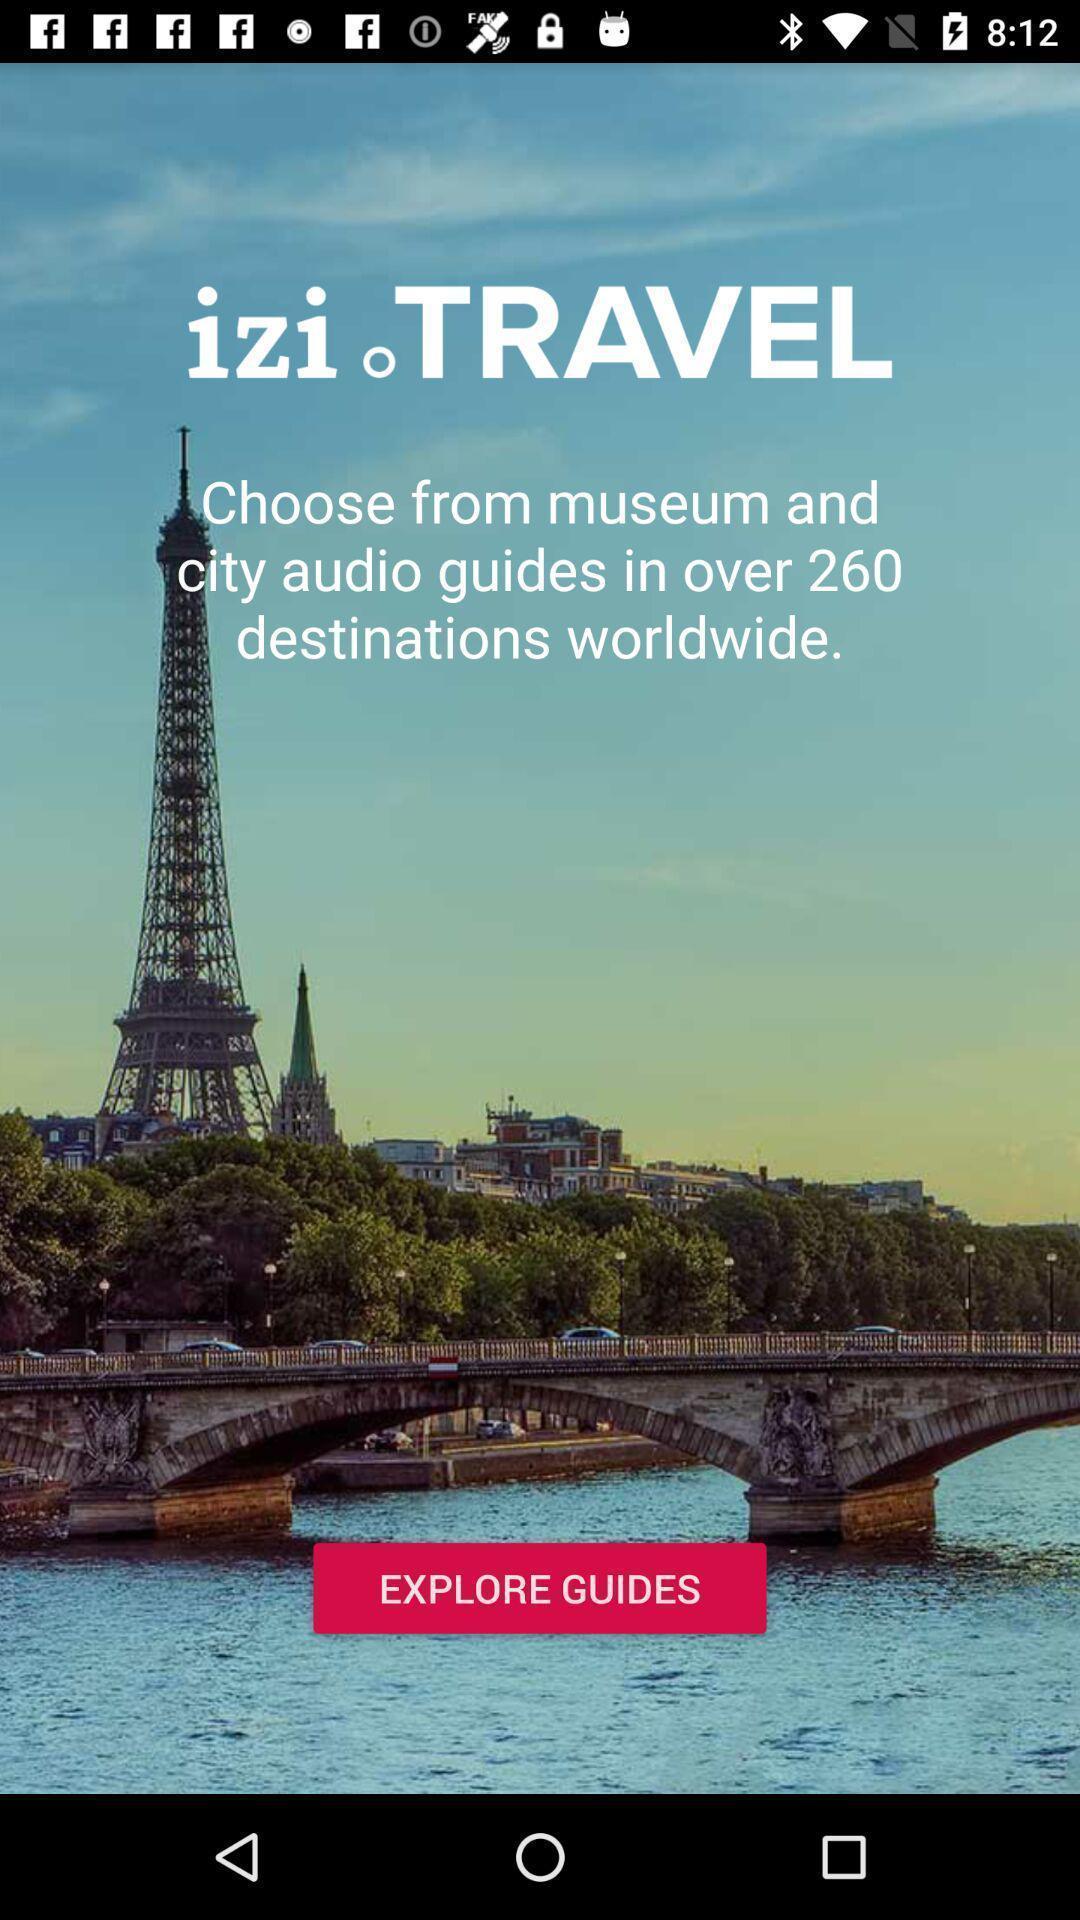Describe the visual elements of this screenshot. Screen displaying the page of a travel app. 